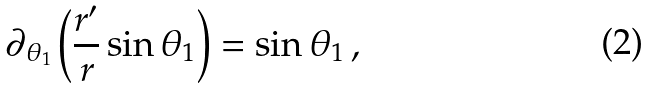Convert formula to latex. <formula><loc_0><loc_0><loc_500><loc_500>\partial _ { \theta _ { 1 } } \left ( \frac { r ^ { \prime } } { r } \sin \theta _ { 1 } \right ) = \sin \theta _ { 1 } \, ,</formula> 